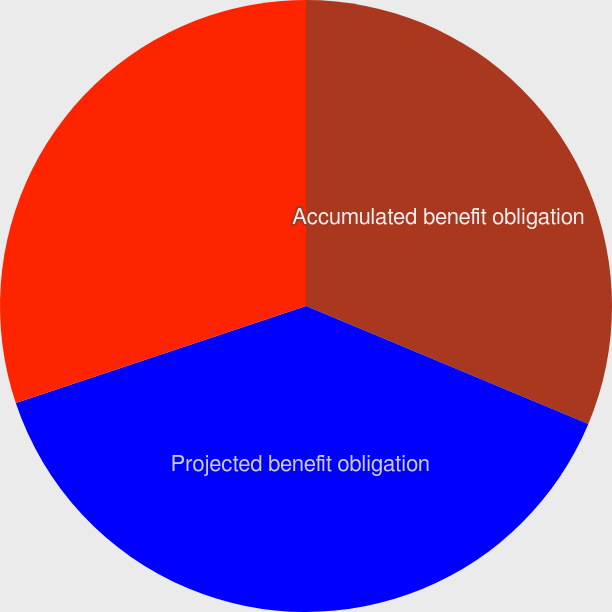<chart> <loc_0><loc_0><loc_500><loc_500><pie_chart><fcel>Accumulated benefit obligation<fcel>Projected benefit obligation<fcel>Fair value of plan assets<nl><fcel>31.3%<fcel>38.56%<fcel>30.14%<nl></chart> 